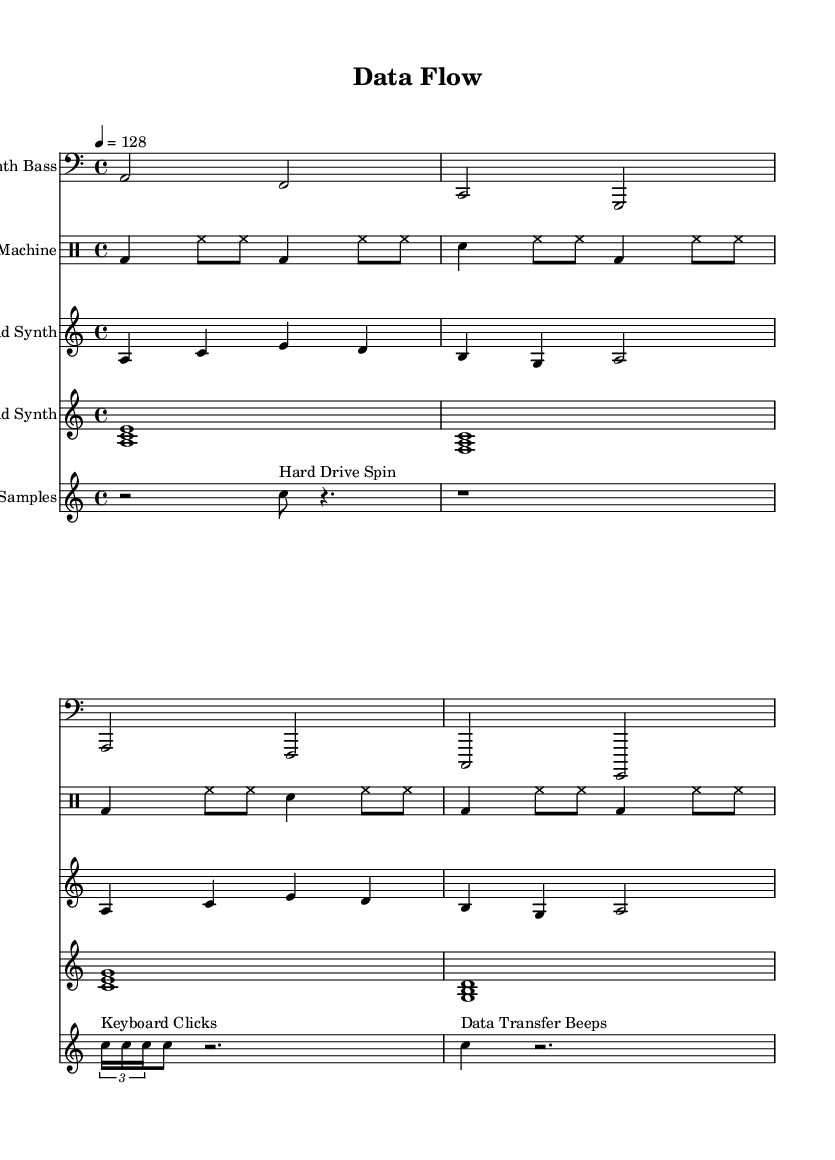What is the key signature of this music? The key signature is indicated at the beginning of the score. It shows one flat, which corresponds to the key of A minor.
Answer: A minor What is the time signature of this music? The time signature is shown after the key signature. It is 4/4, indicating four beats per measure.
Answer: 4/4 What is the tempo marking of this music? The tempo marking found in the score specifies the speed at which the piece should be played, set to 128 beats per minute.
Answer: 128 What instrument plays the computer samples? The instrument name for the staff is clearly labeled as "Computer Samples," indicating that these are the synthesized sounds representing computer hardware.
Answer: Computer Samples Which section features "Keyboard Clicks"? The musical notation indicates that this sound appears within the computer samples section, specifically marked as a tuplet with the note names.
Answer: Computer Samples How many measures does the Synth Bass part have? By counting the number of measures represented in the Synth Bass staff, we find that it consists of four measures, grouped by their bar lines.
Answer: 4 What musical texture is used in the Pad Synth section? The Pad Synth section features a chordal texture, as indicated by the simultaneous occurrence of three notes played together in each measure.
Answer: Chordal 